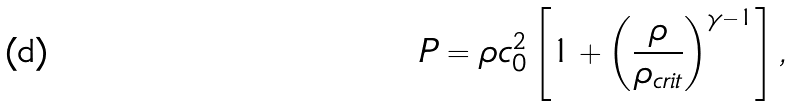<formula> <loc_0><loc_0><loc_500><loc_500>P = \rho c _ { 0 } ^ { 2 } \left [ 1 + \left ( \frac { \rho } { \rho _ { c r i t } } \right ) ^ { \gamma - 1 } \right ] ,</formula> 